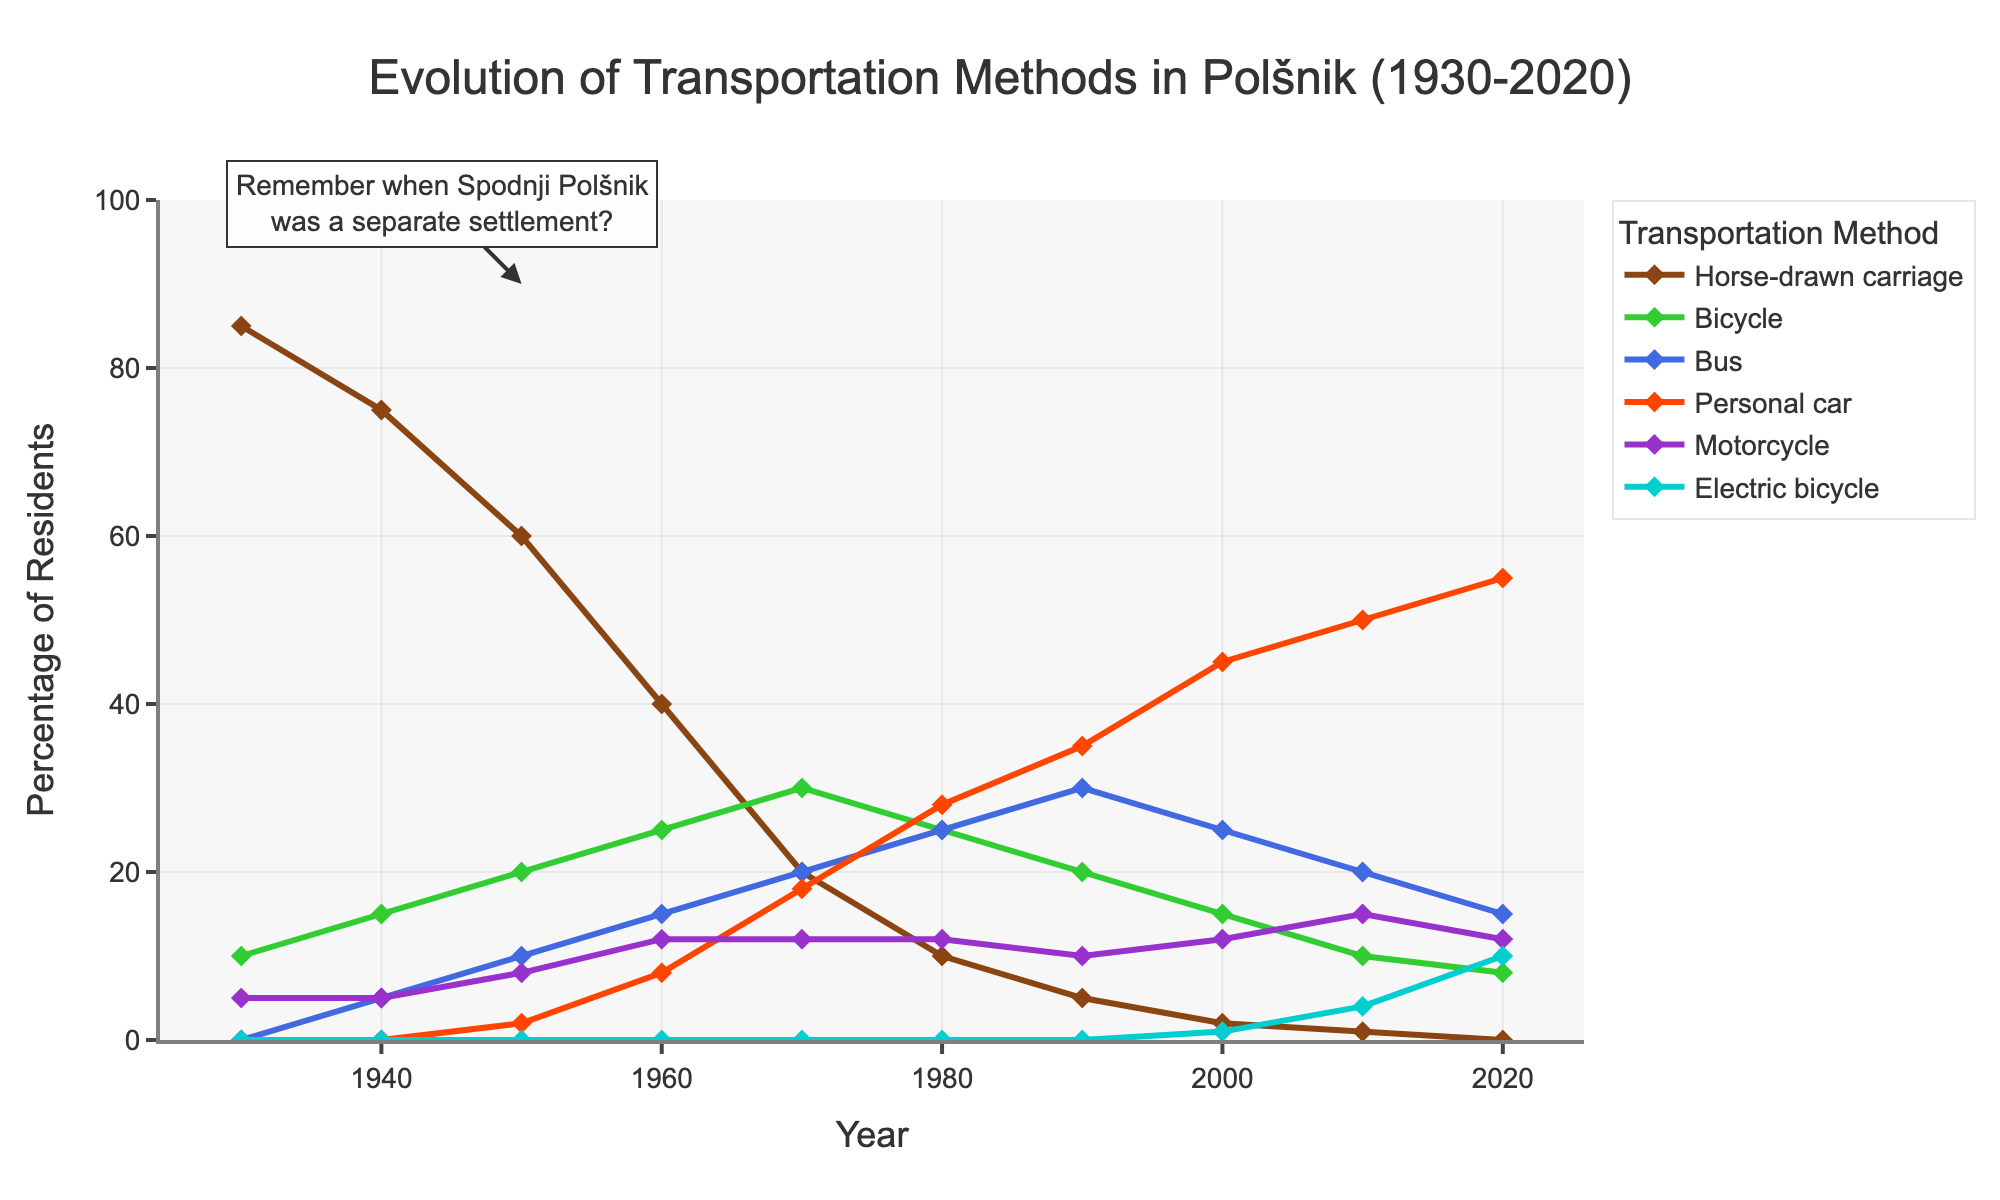What transportation method saw the highest usage in 1930? The figure from 1930 shows six lines representing different methods of transportation. The highest line in 1930 is for Horse-drawn carriage.
Answer: Horse-drawn carriage When did the usage of personal cars first surpass that of buses? To find when the usage of personal cars first overtook buses, we need to look at the lines representing these two methods. From the figure, this happens between 1980 and 1990, specifically by 1990.
Answer: 1990 How many residents used motorcycles in 1960 compared to 2020? Check the specific points on the lines for Motorcycles in 1960 and 2020. In 1960, around 12% were using motorcycles, and in 2020, it was about 12% as well.
Answer: Both 12% What is the total percentage of residents using bicycles and electric bicycles in 2020? Sum the values of Bicycle and Electric bicycle in 2020. Bicycle is 8% and Electric bicycle is 10%, so the total is 8 + 10 = 18%.
Answer: 18% Which transportation method showed a steep decline from 1930 to 2020? Observe the trends in each line from 1930 to 2020. The line for Horse-drawn carriage shows the steepest decline, starting from 85% in 1930 and dropping to 0% in 2020.
Answer: Horse-drawn carriage In which decade did bus usage peak? Find the highest point on the line for Bus usage. The highest point appears around 1990.
Answer: 1990 How does the personal car usage in 1980 compare to that in 2000? Compare the points on the line for Personal car in 1980 and 2000. In 1980, it was 28%, and by 2000, it increased to 45%.
Answer: 1980: 28%, 2000: 45% What can you conclude about the trend in electric bicycle usage from 2000 to 2020? Look at the electric bicycle line between 2000 to 2020. In 2000, electric bicycle usage is minimal (1%), but by 2020, it has significantly increased to 10%. This shows a rising trend.
Answer: Increasing trend Between which years did the usage of horse-drawn carriages decrease the most rapidly? Analyze the steepest slope on the horse-drawn carriage line. The most rapid decline occurs between 1950 and 1960, from 60% to 40%.
Answer: 1950-1960 What notable change happened in bicycle usage from 1970 to 1980? Look at the bicycle line for 1970 (30%) and 1980 (25%). The usage of bicycles decreased by 5% during this decade.
Answer: 5% decrease 